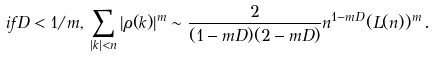Convert formula to latex. <formula><loc_0><loc_0><loc_500><loc_500>i f D < 1 / m , \, \sum _ { | k | < n } | \rho ( k ) | ^ { m } \sim \frac { 2 } { ( 1 - m D ) ( 2 - m D ) } n ^ { 1 - m D } ( L ( n ) ) ^ { m } \, .</formula> 